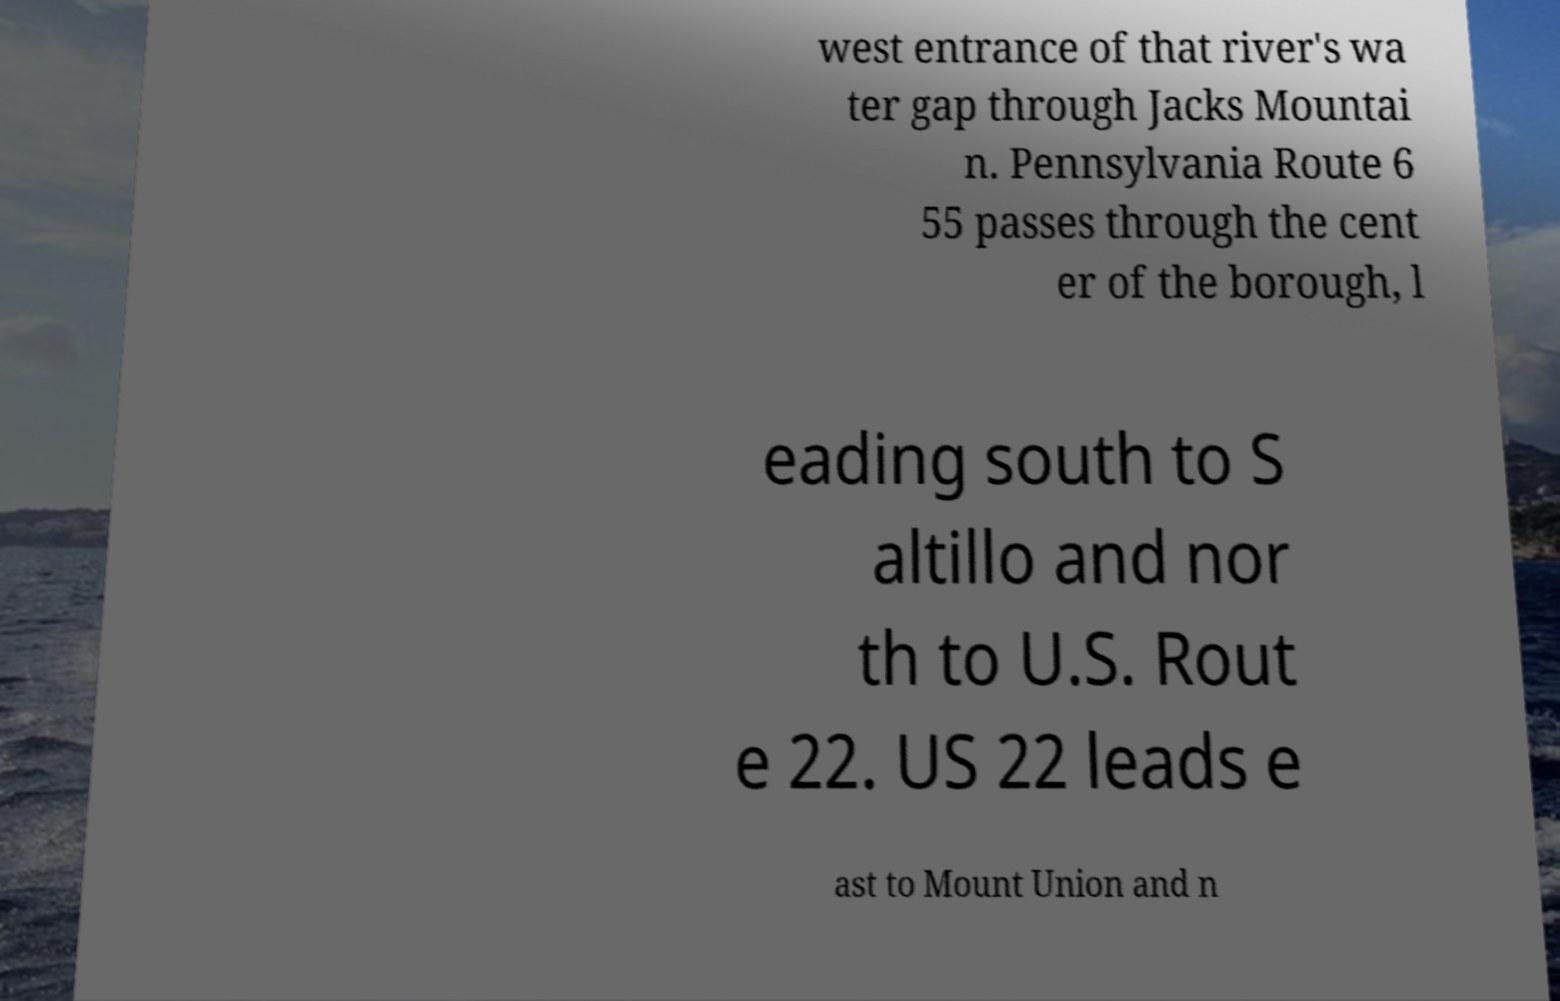Please read and relay the text visible in this image. What does it say? west entrance of that river's wa ter gap through Jacks Mountai n. Pennsylvania Route 6 55 passes through the cent er of the borough, l eading south to S altillo and nor th to U.S. Rout e 22. US 22 leads e ast to Mount Union and n 